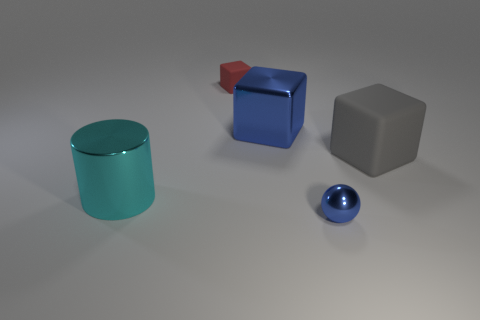There is a rubber thing on the right side of the thing that is in front of the big cyan thing that is to the left of the tiny blue thing; how big is it?
Make the answer very short. Large. Is the material of the sphere the same as the large thing left of the red thing?
Your answer should be compact. Yes. Is the small blue metallic thing the same shape as the small matte object?
Your response must be concise. No. How many other objects are the same material as the gray cube?
Offer a very short reply. 1. What number of gray metal things have the same shape as the small red thing?
Your answer should be compact. 0. The metal thing that is behind the tiny blue metal ball and in front of the metal block is what color?
Provide a short and direct response. Cyan. How many big blue metallic balls are there?
Your answer should be compact. 0. Is the size of the cyan cylinder the same as the shiny block?
Ensure brevity in your answer.  Yes. Is there a tiny ball that has the same color as the big shiny cylinder?
Ensure brevity in your answer.  No. Is the shape of the cyan metallic thing that is left of the gray rubber thing the same as  the gray rubber thing?
Keep it short and to the point. No. 